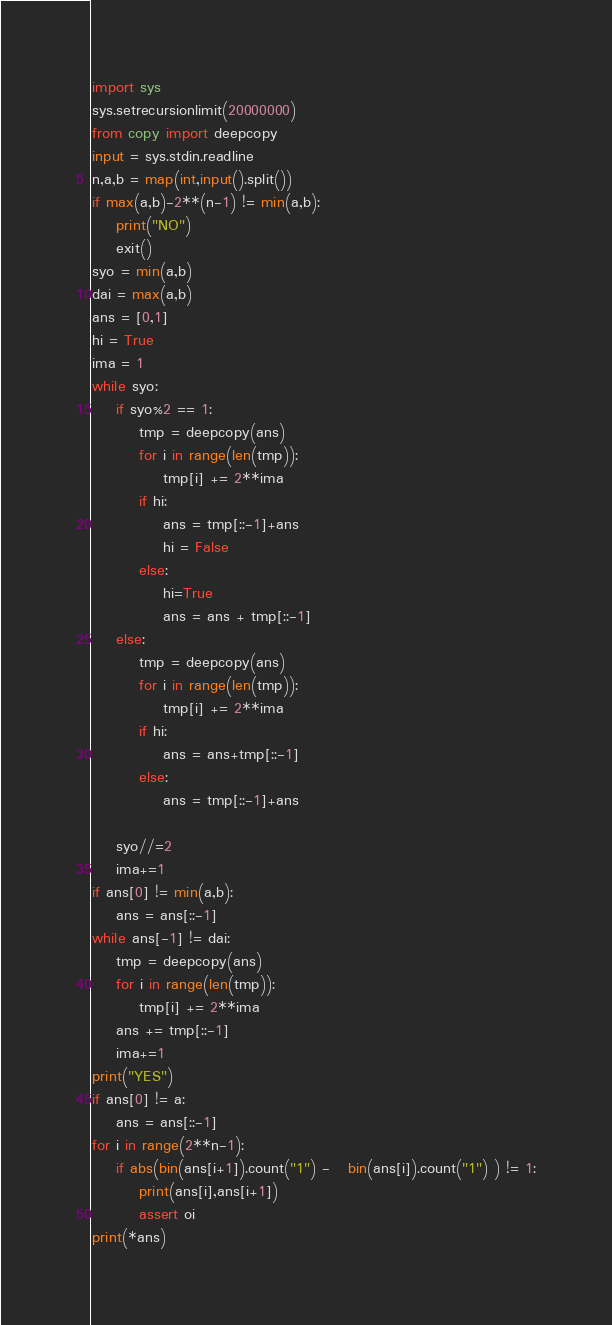Convert code to text. <code><loc_0><loc_0><loc_500><loc_500><_Python_>import sys
sys.setrecursionlimit(20000000)
from copy import deepcopy
input = sys.stdin.readline
n,a,b = map(int,input().split())
if max(a,b)-2**(n-1) != min(a,b):
    print("NO")
    exit()
syo = min(a,b)
dai = max(a,b)
ans = [0,1]
hi = True
ima = 1
while syo:
    if syo%2 == 1:
        tmp = deepcopy(ans)
        for i in range(len(tmp)):
            tmp[i] += 2**ima
        if hi:
            ans = tmp[::-1]+ans
            hi = False
        else:
            hi=True
            ans = ans + tmp[::-1]
    else:
        tmp = deepcopy(ans)
        for i in range(len(tmp)):
            tmp[i] += 2**ima
        if hi:
            ans = ans+tmp[::-1]
        else:
            ans = tmp[::-1]+ans
        
    syo//=2
    ima+=1
if ans[0] != min(a,b):
    ans = ans[::-1]
while ans[-1] != dai:
    tmp = deepcopy(ans)
    for i in range(len(tmp)):
        tmp[i] += 2**ima
    ans += tmp[::-1]
    ima+=1
print("YES")
if ans[0] != a:
    ans = ans[::-1]
for i in range(2**n-1):
    if abs(bin(ans[i+1]).count("1") -   bin(ans[i]).count("1") ) != 1:
        print(ans[i],ans[i+1])
        assert oi
print(*ans)</code> 